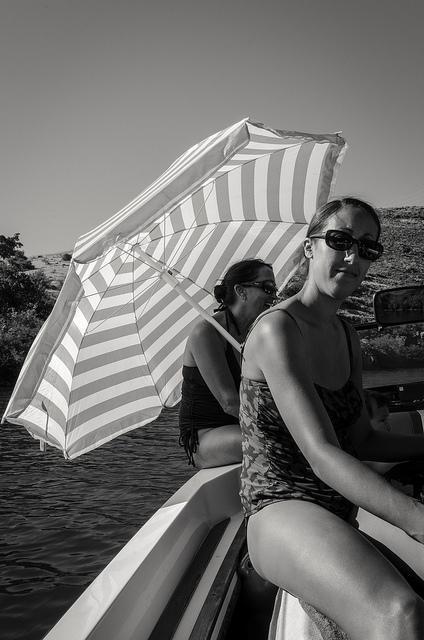How many people can be seen?
Give a very brief answer. 2. 